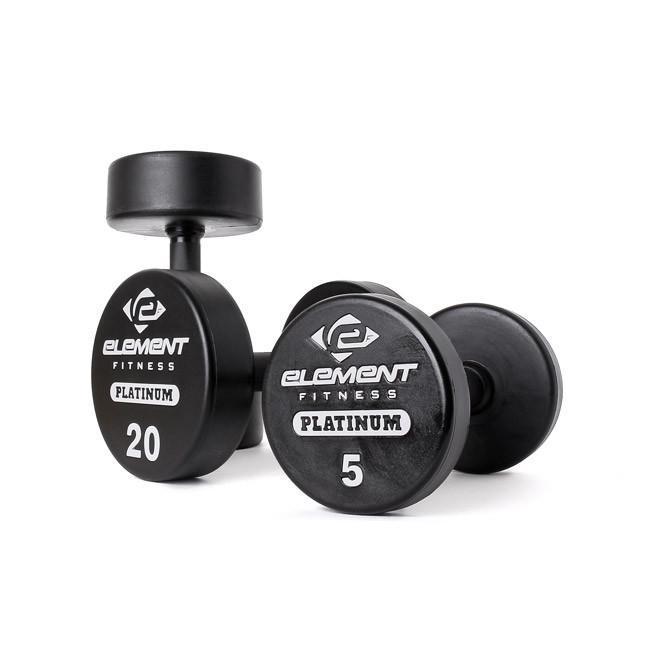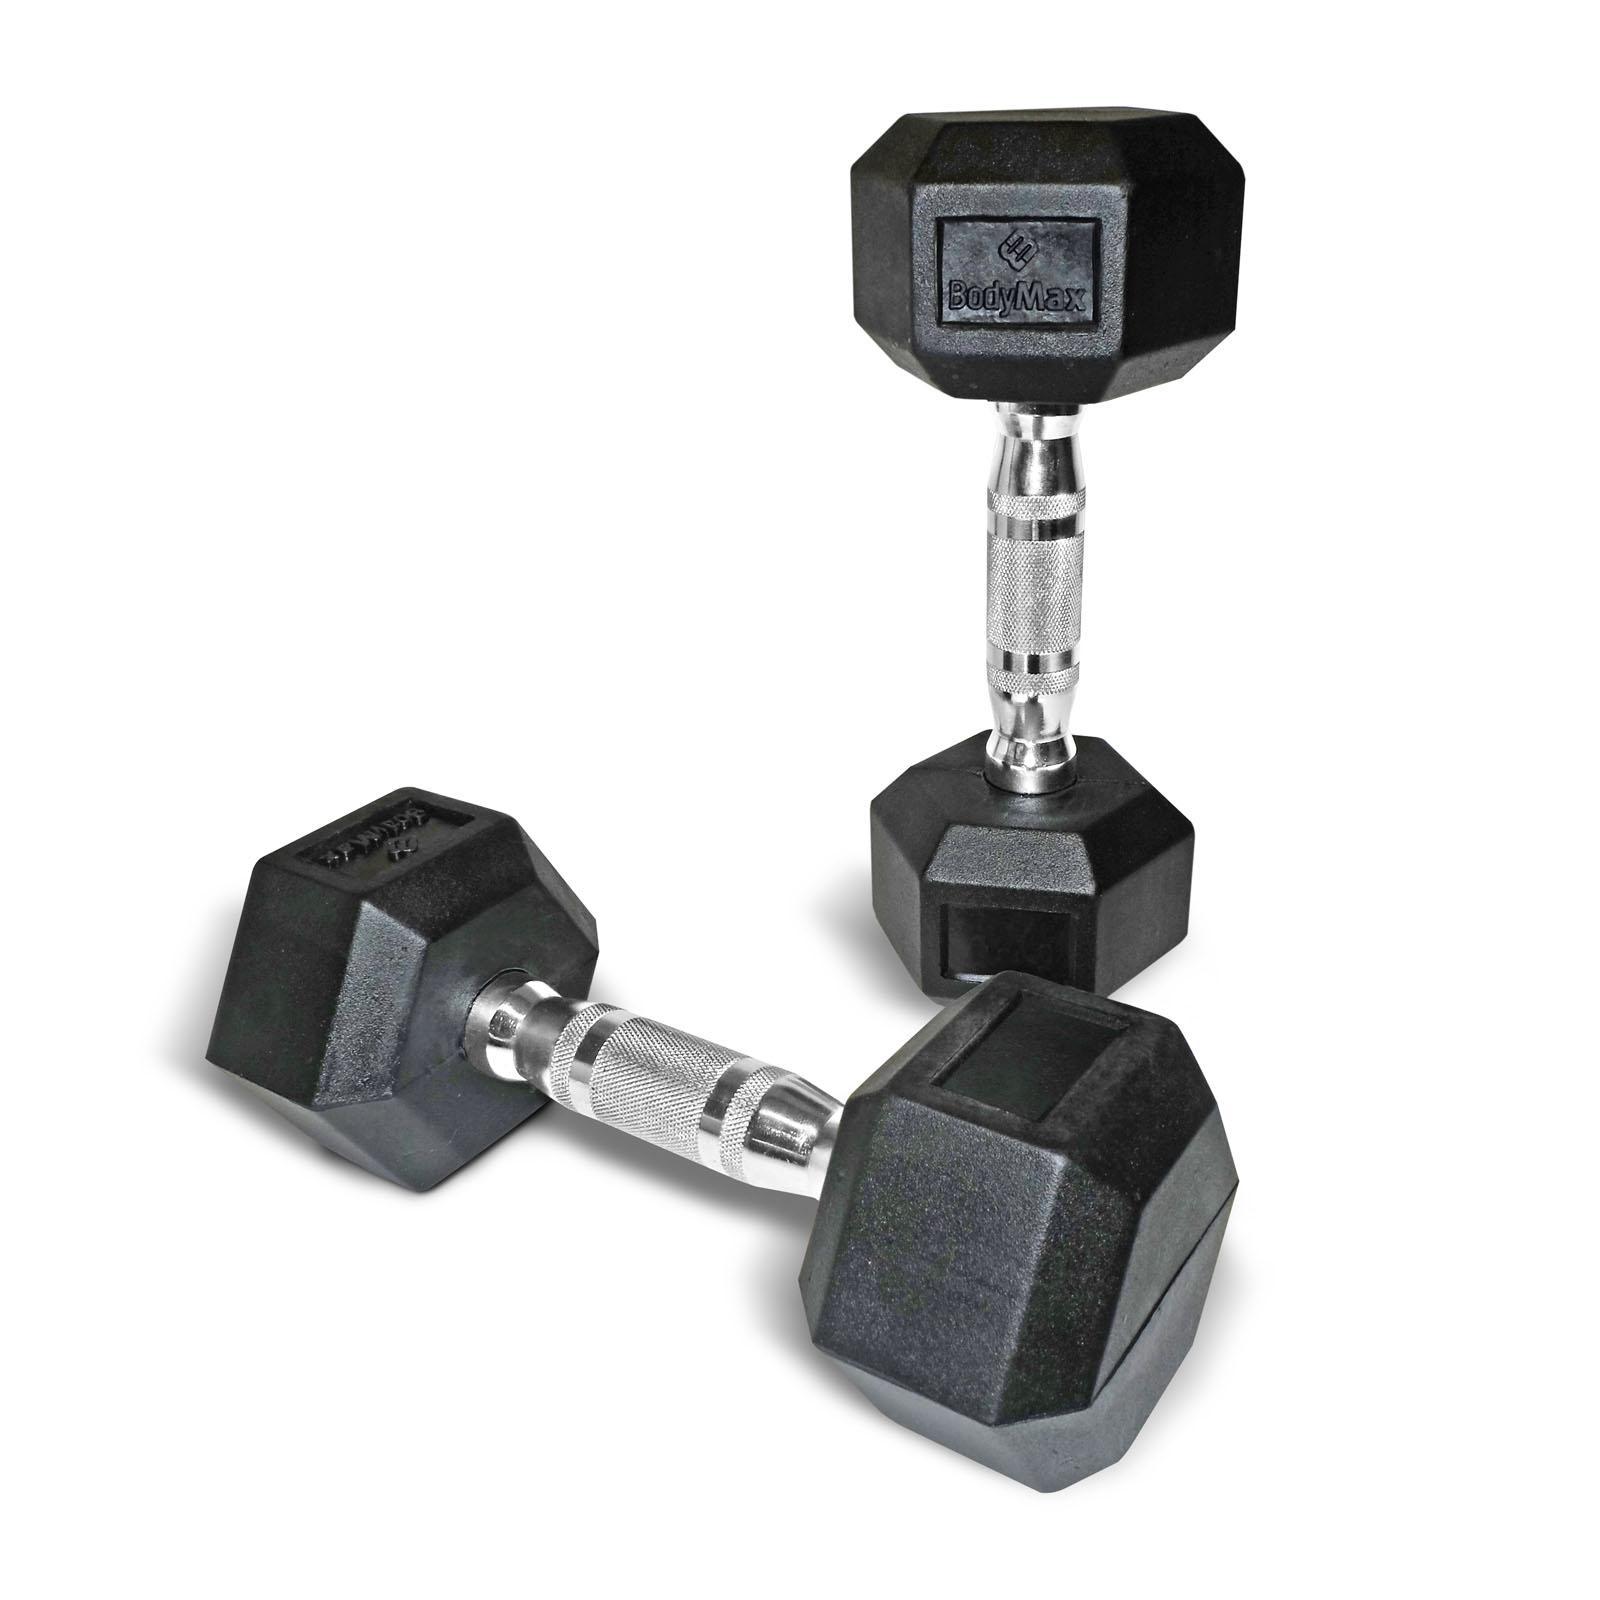The first image is the image on the left, the second image is the image on the right. Analyze the images presented: Is the assertion "There are more dumbbells in the right image than in the left image." valid? Answer yes or no. No. 